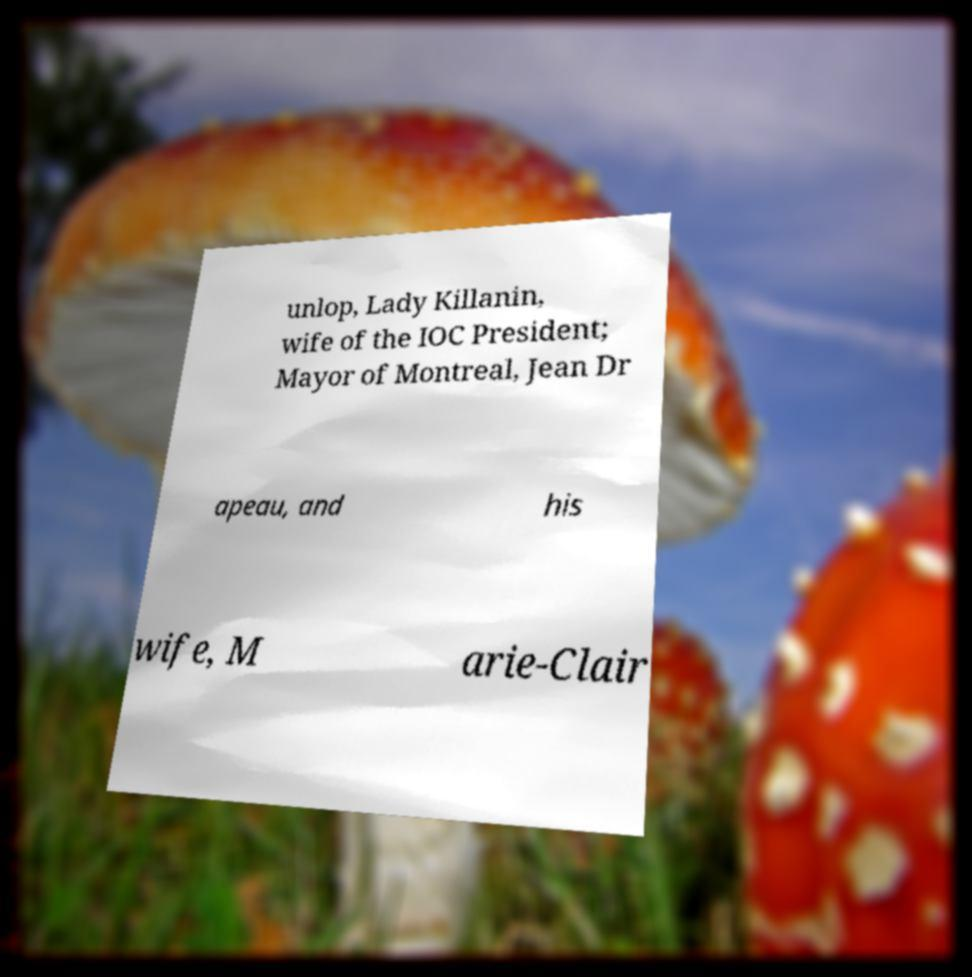Could you extract and type out the text from this image? unlop, Lady Killanin, wife of the IOC President; Mayor of Montreal, Jean Dr apeau, and his wife, M arie-Clair 